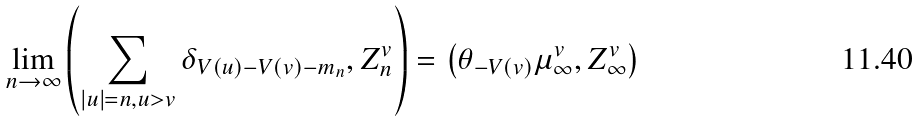Convert formula to latex. <formula><loc_0><loc_0><loc_500><loc_500>\lim _ { n \to \infty } \left ( \sum _ { | u | = n , u > v } \delta _ { V ( u ) - V ( v ) - m _ { n } } , Z ^ { v } _ { n } \right ) = \left ( \theta _ { - V ( v ) } \mu ^ { v } _ { \infty } , Z ^ { v } _ { \infty } \right )</formula> 